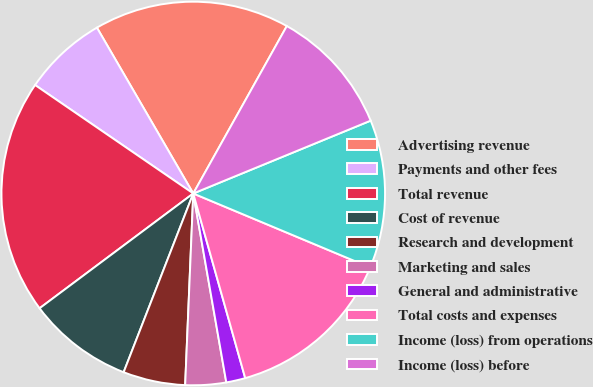<chart> <loc_0><loc_0><loc_500><loc_500><pie_chart><fcel>Advertising revenue<fcel>Payments and other fees<fcel>Total revenue<fcel>Cost of revenue<fcel>Research and development<fcel>Marketing and sales<fcel>General and administrative<fcel>Total costs and expenses<fcel>Income (loss) from operations<fcel>Income (loss) before<nl><fcel>16.49%<fcel>7.06%<fcel>19.78%<fcel>8.88%<fcel>5.24%<fcel>3.43%<fcel>1.61%<fcel>14.33%<fcel>12.51%<fcel>10.69%<nl></chart> 